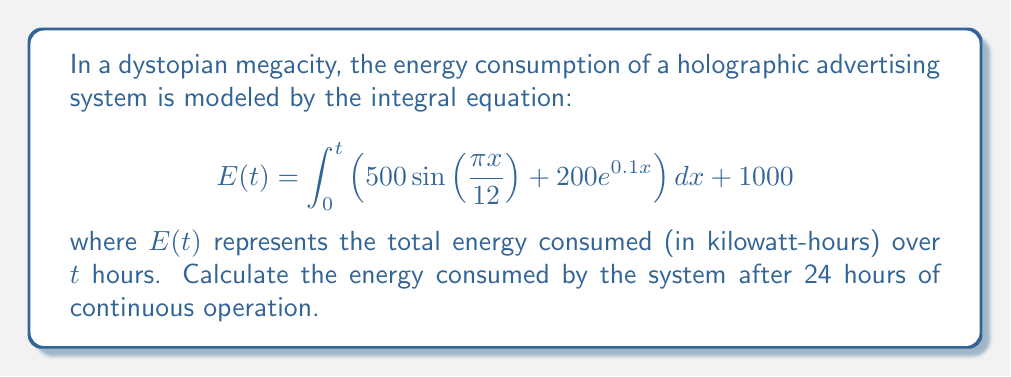Could you help me with this problem? To solve this problem, we need to evaluate the definite integral from 0 to 24 and add the constant term. Let's break it down step-by-step:

1. Split the integral into two parts:
   $$E(24) = \int_0^{24} 500\sin(\frac{\pi x}{12}) dx + \int_0^{24} 200e^{0.1x} dx + 1000$$

2. Evaluate the first integral:
   $$\int_0^{24} 500\sin(\frac{\pi x}{12}) dx = -500 \cdot \frac{12}{\pi} \cos(\frac{\pi x}{12}) \bigg|_0^{24}$$
   $$= -\frac{6000}{\pi} \left[\cos(2\pi) - \cos(0)\right] = 0$$

3. Evaluate the second integral:
   $$\int_0^{24} 200e^{0.1x} dx = 2000 \cdot \frac{1}{0.1} e^{0.1x} \bigg|_0^{24}$$
   $$= 20000 \left[e^{2.4} - 1\right] \approx 201,375.27$$

4. Sum up the results and add the constant term:
   $$E(24) = 0 + 201,375.27 + 1000 = 202,375.27$$

Therefore, the energy consumed by the holographic advertising system after 24 hours is approximately 202,375.27 kilowatt-hours.
Answer: 202,375.27 kWh 